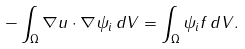<formula> <loc_0><loc_0><loc_500><loc_500>- \int _ { \Omega } \nabla u \cdot \nabla \psi _ { i } \, d V = \int _ { \Omega } \psi _ { i } f \, d V .</formula> 